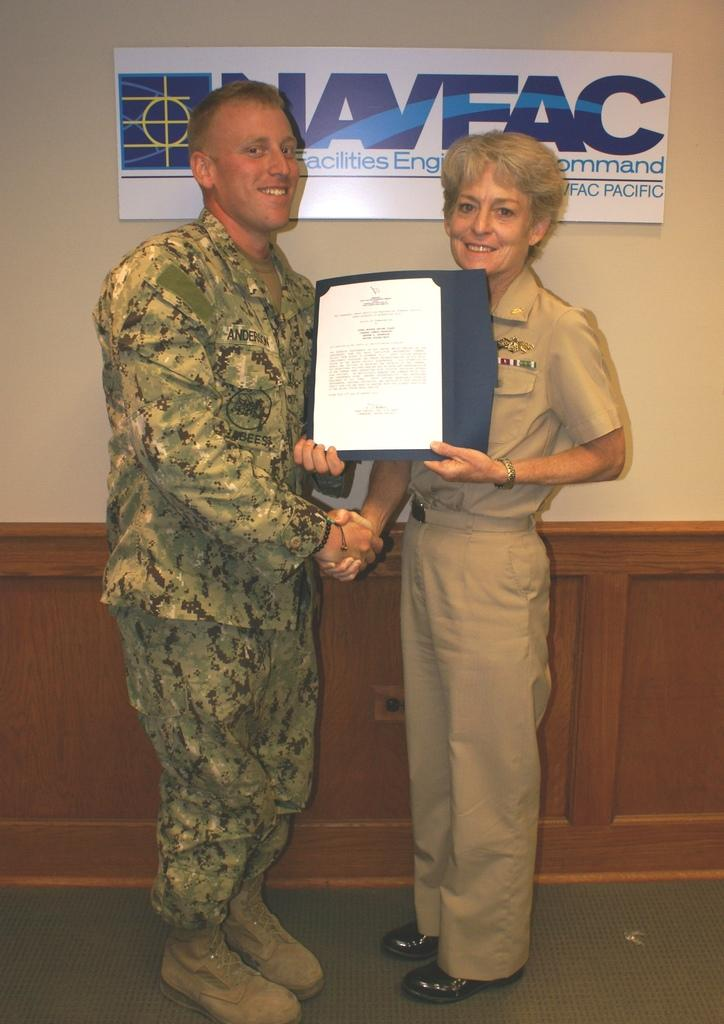<image>
Share a concise interpretation of the image provided. Two soldiers shake hands while holding a piece of paper, a banner for UAVFAC hangs behind them. 